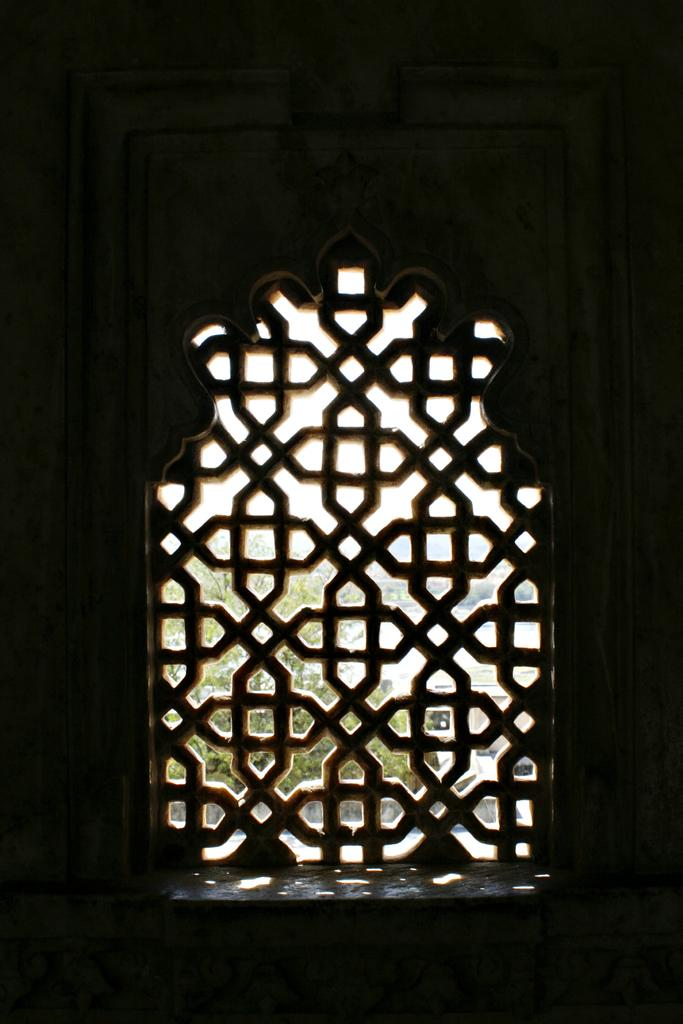What type of view does the image provide? The image is an inside view. What is present on the wall in the image? There is a window in the wall. What can be seen through the window? The outside view is visible through the window. What natural element is present in the outside view? There is a tree in the outside view. What man-made structures are visible in the outside view? There are buildings in the outside view. Can you see a rabbit hopping around in the image? A: There is no rabbit present in the image. Is there an army marching past the buildings in the image? There is no army or marching activity visible in the image. 